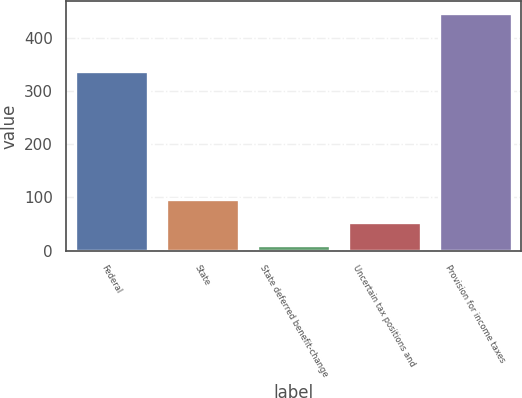Convert chart to OTSL. <chart><loc_0><loc_0><loc_500><loc_500><bar_chart><fcel>Federal<fcel>State<fcel>State deferred benefit-change<fcel>Uncertain tax positions and<fcel>Provision for income taxes<nl><fcel>337.6<fcel>97.5<fcel>10.5<fcel>54<fcel>445.5<nl></chart> 